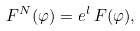Convert formula to latex. <formula><loc_0><loc_0><loc_500><loc_500>F ^ { N } ( \varphi ) = e ^ { l } \, F ( \varphi ) ,</formula> 